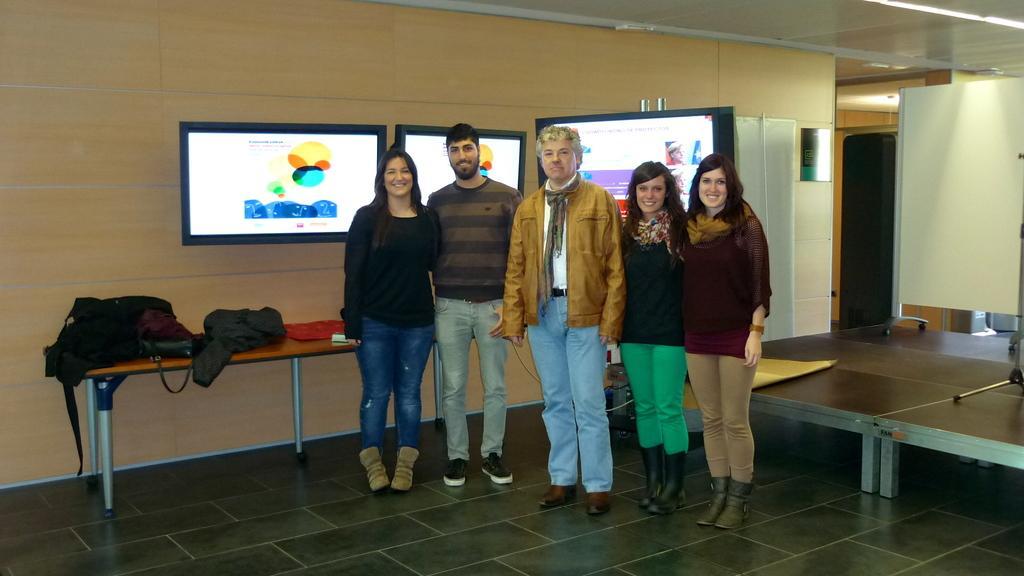Describe this image in one or two sentences. In this picture there are many people standing. In the background we observe screens attached to the wall and to the right side of the image there is a white board on top of a table. 